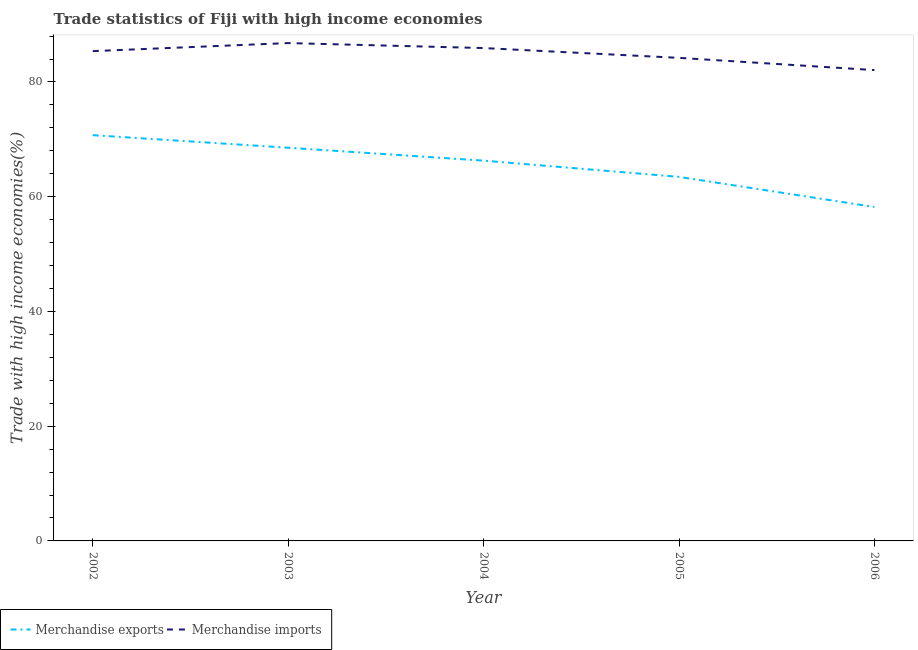Does the line corresponding to merchandise exports intersect with the line corresponding to merchandise imports?
Give a very brief answer. No. What is the merchandise imports in 2005?
Give a very brief answer. 84.2. Across all years, what is the maximum merchandise imports?
Your response must be concise. 86.78. Across all years, what is the minimum merchandise exports?
Offer a very short reply. 58.21. In which year was the merchandise imports minimum?
Make the answer very short. 2006. What is the total merchandise exports in the graph?
Offer a terse response. 327.21. What is the difference between the merchandise exports in 2003 and that in 2005?
Provide a short and direct response. 5.08. What is the difference between the merchandise imports in 2003 and the merchandise exports in 2005?
Your answer should be compact. 23.32. What is the average merchandise imports per year?
Your answer should be compact. 84.87. In the year 2003, what is the difference between the merchandise imports and merchandise exports?
Provide a short and direct response. 18.24. What is the ratio of the merchandise exports in 2003 to that in 2006?
Provide a short and direct response. 1.18. Is the merchandise imports in 2004 less than that in 2005?
Your answer should be compact. No. What is the difference between the highest and the second highest merchandise exports?
Keep it short and to the point. 2.19. What is the difference between the highest and the lowest merchandise exports?
Your response must be concise. 12.52. In how many years, is the merchandise imports greater than the average merchandise imports taken over all years?
Your answer should be compact. 3. Does the merchandise imports monotonically increase over the years?
Your response must be concise. No. How many lines are there?
Your answer should be very brief. 2. What is the difference between two consecutive major ticks on the Y-axis?
Keep it short and to the point. 20. Are the values on the major ticks of Y-axis written in scientific E-notation?
Offer a terse response. No. Does the graph contain any zero values?
Provide a succinct answer. No. Does the graph contain grids?
Provide a short and direct response. No. How are the legend labels stacked?
Provide a short and direct response. Horizontal. What is the title of the graph?
Make the answer very short. Trade statistics of Fiji with high income economies. What is the label or title of the X-axis?
Your answer should be very brief. Year. What is the label or title of the Y-axis?
Ensure brevity in your answer.  Trade with high income economies(%). What is the Trade with high income economies(%) in Merchandise exports in 2002?
Keep it short and to the point. 70.73. What is the Trade with high income economies(%) in Merchandise imports in 2002?
Provide a short and direct response. 85.37. What is the Trade with high income economies(%) in Merchandise exports in 2003?
Give a very brief answer. 68.54. What is the Trade with high income economies(%) in Merchandise imports in 2003?
Ensure brevity in your answer.  86.78. What is the Trade with high income economies(%) in Merchandise exports in 2004?
Your answer should be compact. 66.29. What is the Trade with high income economies(%) of Merchandise imports in 2004?
Your answer should be very brief. 85.91. What is the Trade with high income economies(%) in Merchandise exports in 2005?
Offer a very short reply. 63.46. What is the Trade with high income economies(%) of Merchandise imports in 2005?
Provide a succinct answer. 84.2. What is the Trade with high income economies(%) in Merchandise exports in 2006?
Keep it short and to the point. 58.21. What is the Trade with high income economies(%) in Merchandise imports in 2006?
Provide a succinct answer. 82.07. Across all years, what is the maximum Trade with high income economies(%) in Merchandise exports?
Ensure brevity in your answer.  70.73. Across all years, what is the maximum Trade with high income economies(%) in Merchandise imports?
Keep it short and to the point. 86.78. Across all years, what is the minimum Trade with high income economies(%) of Merchandise exports?
Offer a very short reply. 58.21. Across all years, what is the minimum Trade with high income economies(%) of Merchandise imports?
Offer a terse response. 82.07. What is the total Trade with high income economies(%) of Merchandise exports in the graph?
Give a very brief answer. 327.21. What is the total Trade with high income economies(%) of Merchandise imports in the graph?
Your answer should be very brief. 424.33. What is the difference between the Trade with high income economies(%) of Merchandise exports in 2002 and that in 2003?
Keep it short and to the point. 2.19. What is the difference between the Trade with high income economies(%) in Merchandise imports in 2002 and that in 2003?
Give a very brief answer. -1.4. What is the difference between the Trade with high income economies(%) of Merchandise exports in 2002 and that in 2004?
Ensure brevity in your answer.  4.44. What is the difference between the Trade with high income economies(%) of Merchandise imports in 2002 and that in 2004?
Ensure brevity in your answer.  -0.54. What is the difference between the Trade with high income economies(%) of Merchandise exports in 2002 and that in 2005?
Provide a short and direct response. 7.27. What is the difference between the Trade with high income economies(%) in Merchandise imports in 2002 and that in 2005?
Your response must be concise. 1.17. What is the difference between the Trade with high income economies(%) of Merchandise exports in 2002 and that in 2006?
Provide a succinct answer. 12.52. What is the difference between the Trade with high income economies(%) in Merchandise imports in 2002 and that in 2006?
Provide a succinct answer. 3.31. What is the difference between the Trade with high income economies(%) of Merchandise exports in 2003 and that in 2004?
Provide a short and direct response. 2.25. What is the difference between the Trade with high income economies(%) of Merchandise imports in 2003 and that in 2004?
Provide a succinct answer. 0.87. What is the difference between the Trade with high income economies(%) of Merchandise exports in 2003 and that in 2005?
Provide a short and direct response. 5.08. What is the difference between the Trade with high income economies(%) in Merchandise imports in 2003 and that in 2005?
Your answer should be compact. 2.58. What is the difference between the Trade with high income economies(%) in Merchandise exports in 2003 and that in 2006?
Make the answer very short. 10.33. What is the difference between the Trade with high income economies(%) of Merchandise imports in 2003 and that in 2006?
Provide a succinct answer. 4.71. What is the difference between the Trade with high income economies(%) in Merchandise exports in 2004 and that in 2005?
Give a very brief answer. 2.83. What is the difference between the Trade with high income economies(%) of Merchandise imports in 2004 and that in 2005?
Offer a terse response. 1.71. What is the difference between the Trade with high income economies(%) in Merchandise exports in 2004 and that in 2006?
Your answer should be compact. 8.08. What is the difference between the Trade with high income economies(%) in Merchandise imports in 2004 and that in 2006?
Offer a terse response. 3.84. What is the difference between the Trade with high income economies(%) of Merchandise exports in 2005 and that in 2006?
Provide a succinct answer. 5.25. What is the difference between the Trade with high income economies(%) in Merchandise imports in 2005 and that in 2006?
Your response must be concise. 2.13. What is the difference between the Trade with high income economies(%) in Merchandise exports in 2002 and the Trade with high income economies(%) in Merchandise imports in 2003?
Keep it short and to the point. -16.05. What is the difference between the Trade with high income economies(%) of Merchandise exports in 2002 and the Trade with high income economies(%) of Merchandise imports in 2004?
Ensure brevity in your answer.  -15.18. What is the difference between the Trade with high income economies(%) in Merchandise exports in 2002 and the Trade with high income economies(%) in Merchandise imports in 2005?
Your response must be concise. -13.48. What is the difference between the Trade with high income economies(%) in Merchandise exports in 2002 and the Trade with high income economies(%) in Merchandise imports in 2006?
Offer a very short reply. -11.34. What is the difference between the Trade with high income economies(%) in Merchandise exports in 2003 and the Trade with high income economies(%) in Merchandise imports in 2004?
Keep it short and to the point. -17.37. What is the difference between the Trade with high income economies(%) in Merchandise exports in 2003 and the Trade with high income economies(%) in Merchandise imports in 2005?
Your response must be concise. -15.66. What is the difference between the Trade with high income economies(%) of Merchandise exports in 2003 and the Trade with high income economies(%) of Merchandise imports in 2006?
Your answer should be compact. -13.53. What is the difference between the Trade with high income economies(%) in Merchandise exports in 2004 and the Trade with high income economies(%) in Merchandise imports in 2005?
Make the answer very short. -17.91. What is the difference between the Trade with high income economies(%) in Merchandise exports in 2004 and the Trade with high income economies(%) in Merchandise imports in 2006?
Your answer should be compact. -15.78. What is the difference between the Trade with high income economies(%) of Merchandise exports in 2005 and the Trade with high income economies(%) of Merchandise imports in 2006?
Make the answer very short. -18.61. What is the average Trade with high income economies(%) of Merchandise exports per year?
Provide a short and direct response. 65.44. What is the average Trade with high income economies(%) in Merchandise imports per year?
Provide a succinct answer. 84.87. In the year 2002, what is the difference between the Trade with high income economies(%) in Merchandise exports and Trade with high income economies(%) in Merchandise imports?
Your answer should be very brief. -14.65. In the year 2003, what is the difference between the Trade with high income economies(%) in Merchandise exports and Trade with high income economies(%) in Merchandise imports?
Ensure brevity in your answer.  -18.24. In the year 2004, what is the difference between the Trade with high income economies(%) in Merchandise exports and Trade with high income economies(%) in Merchandise imports?
Your answer should be compact. -19.62. In the year 2005, what is the difference between the Trade with high income economies(%) in Merchandise exports and Trade with high income economies(%) in Merchandise imports?
Offer a very short reply. -20.75. In the year 2006, what is the difference between the Trade with high income economies(%) in Merchandise exports and Trade with high income economies(%) in Merchandise imports?
Provide a succinct answer. -23.86. What is the ratio of the Trade with high income economies(%) of Merchandise exports in 2002 to that in 2003?
Give a very brief answer. 1.03. What is the ratio of the Trade with high income economies(%) in Merchandise imports in 2002 to that in 2003?
Make the answer very short. 0.98. What is the ratio of the Trade with high income economies(%) of Merchandise exports in 2002 to that in 2004?
Ensure brevity in your answer.  1.07. What is the ratio of the Trade with high income economies(%) in Merchandise imports in 2002 to that in 2004?
Provide a succinct answer. 0.99. What is the ratio of the Trade with high income economies(%) of Merchandise exports in 2002 to that in 2005?
Make the answer very short. 1.11. What is the ratio of the Trade with high income economies(%) of Merchandise imports in 2002 to that in 2005?
Offer a terse response. 1.01. What is the ratio of the Trade with high income economies(%) of Merchandise exports in 2002 to that in 2006?
Give a very brief answer. 1.22. What is the ratio of the Trade with high income economies(%) in Merchandise imports in 2002 to that in 2006?
Offer a terse response. 1.04. What is the ratio of the Trade with high income economies(%) of Merchandise exports in 2003 to that in 2004?
Offer a terse response. 1.03. What is the ratio of the Trade with high income economies(%) in Merchandise exports in 2003 to that in 2005?
Make the answer very short. 1.08. What is the ratio of the Trade with high income economies(%) in Merchandise imports in 2003 to that in 2005?
Offer a very short reply. 1.03. What is the ratio of the Trade with high income economies(%) in Merchandise exports in 2003 to that in 2006?
Your response must be concise. 1.18. What is the ratio of the Trade with high income economies(%) in Merchandise imports in 2003 to that in 2006?
Your response must be concise. 1.06. What is the ratio of the Trade with high income economies(%) of Merchandise exports in 2004 to that in 2005?
Keep it short and to the point. 1.04. What is the ratio of the Trade with high income economies(%) in Merchandise imports in 2004 to that in 2005?
Offer a very short reply. 1.02. What is the ratio of the Trade with high income economies(%) in Merchandise exports in 2004 to that in 2006?
Make the answer very short. 1.14. What is the ratio of the Trade with high income economies(%) in Merchandise imports in 2004 to that in 2006?
Your answer should be compact. 1.05. What is the ratio of the Trade with high income economies(%) in Merchandise exports in 2005 to that in 2006?
Your response must be concise. 1.09. What is the difference between the highest and the second highest Trade with high income economies(%) of Merchandise exports?
Ensure brevity in your answer.  2.19. What is the difference between the highest and the second highest Trade with high income economies(%) in Merchandise imports?
Your response must be concise. 0.87. What is the difference between the highest and the lowest Trade with high income economies(%) of Merchandise exports?
Provide a succinct answer. 12.52. What is the difference between the highest and the lowest Trade with high income economies(%) in Merchandise imports?
Provide a short and direct response. 4.71. 